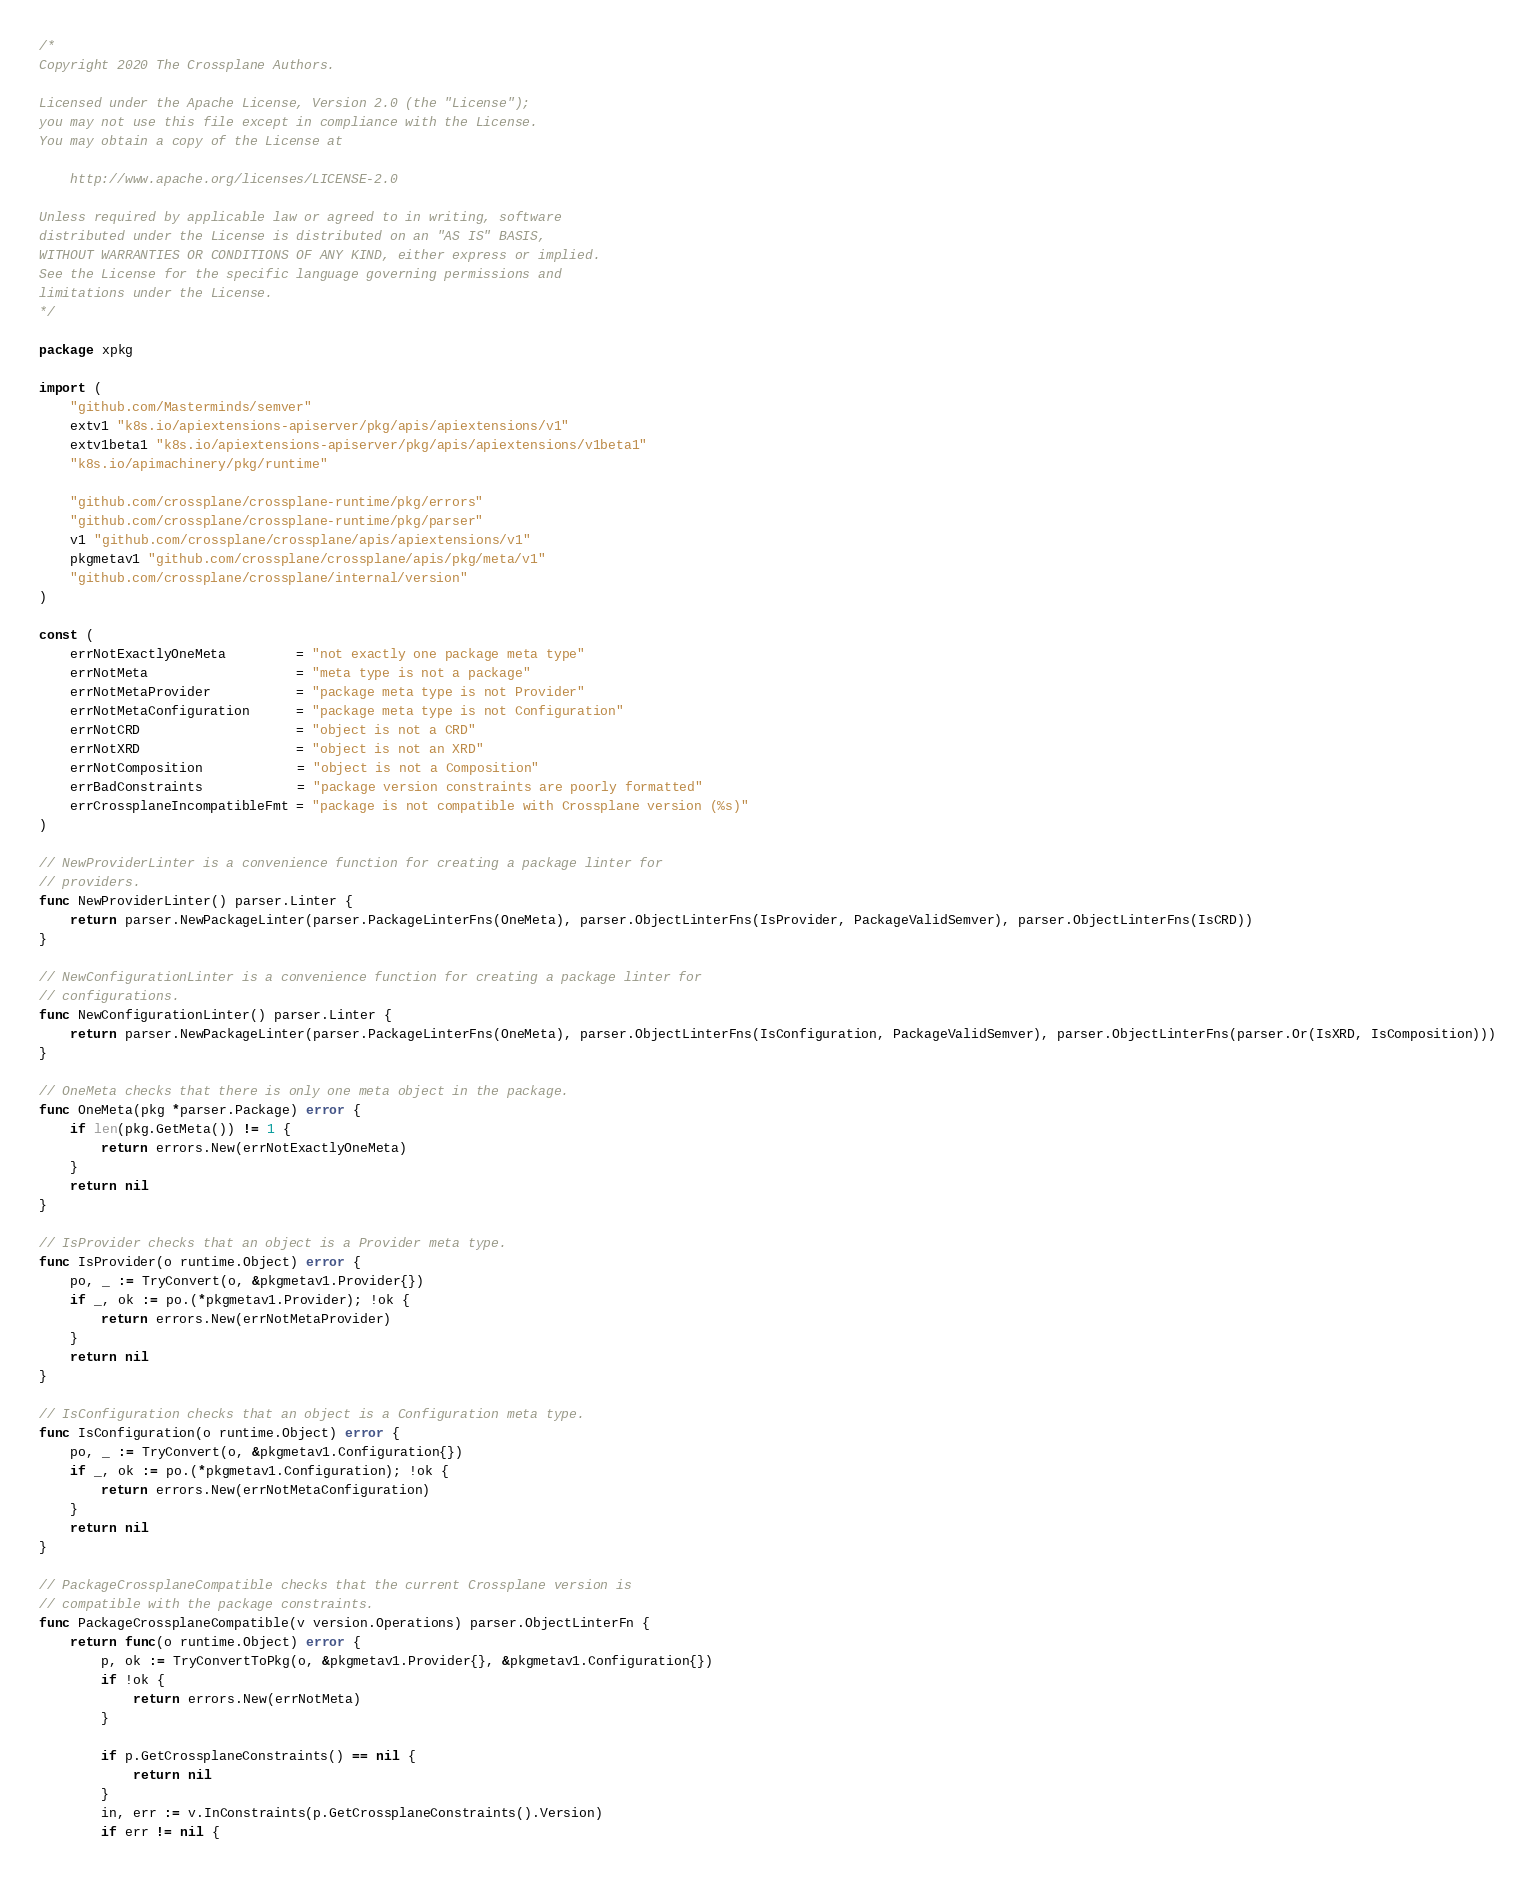Convert code to text. <code><loc_0><loc_0><loc_500><loc_500><_Go_>/*
Copyright 2020 The Crossplane Authors.

Licensed under the Apache License, Version 2.0 (the "License");
you may not use this file except in compliance with the License.
You may obtain a copy of the License at

    http://www.apache.org/licenses/LICENSE-2.0

Unless required by applicable law or agreed to in writing, software
distributed under the License is distributed on an "AS IS" BASIS,
WITHOUT WARRANTIES OR CONDITIONS OF ANY KIND, either express or implied.
See the License for the specific language governing permissions and
limitations under the License.
*/

package xpkg

import (
	"github.com/Masterminds/semver"
	extv1 "k8s.io/apiextensions-apiserver/pkg/apis/apiextensions/v1"
	extv1beta1 "k8s.io/apiextensions-apiserver/pkg/apis/apiextensions/v1beta1"
	"k8s.io/apimachinery/pkg/runtime"

	"github.com/crossplane/crossplane-runtime/pkg/errors"
	"github.com/crossplane/crossplane-runtime/pkg/parser"
	v1 "github.com/crossplane/crossplane/apis/apiextensions/v1"
	pkgmetav1 "github.com/crossplane/crossplane/apis/pkg/meta/v1"
	"github.com/crossplane/crossplane/internal/version"
)

const (
	errNotExactlyOneMeta         = "not exactly one package meta type"
	errNotMeta                   = "meta type is not a package"
	errNotMetaProvider           = "package meta type is not Provider"
	errNotMetaConfiguration      = "package meta type is not Configuration"
	errNotCRD                    = "object is not a CRD"
	errNotXRD                    = "object is not an XRD"
	errNotComposition            = "object is not a Composition"
	errBadConstraints            = "package version constraints are poorly formatted"
	errCrossplaneIncompatibleFmt = "package is not compatible with Crossplane version (%s)"
)

// NewProviderLinter is a convenience function for creating a package linter for
// providers.
func NewProviderLinter() parser.Linter {
	return parser.NewPackageLinter(parser.PackageLinterFns(OneMeta), parser.ObjectLinterFns(IsProvider, PackageValidSemver), parser.ObjectLinterFns(IsCRD))
}

// NewConfigurationLinter is a convenience function for creating a package linter for
// configurations.
func NewConfigurationLinter() parser.Linter {
	return parser.NewPackageLinter(parser.PackageLinterFns(OneMeta), parser.ObjectLinterFns(IsConfiguration, PackageValidSemver), parser.ObjectLinterFns(parser.Or(IsXRD, IsComposition)))
}

// OneMeta checks that there is only one meta object in the package.
func OneMeta(pkg *parser.Package) error {
	if len(pkg.GetMeta()) != 1 {
		return errors.New(errNotExactlyOneMeta)
	}
	return nil
}

// IsProvider checks that an object is a Provider meta type.
func IsProvider(o runtime.Object) error {
	po, _ := TryConvert(o, &pkgmetav1.Provider{})
	if _, ok := po.(*pkgmetav1.Provider); !ok {
		return errors.New(errNotMetaProvider)
	}
	return nil
}

// IsConfiguration checks that an object is a Configuration meta type.
func IsConfiguration(o runtime.Object) error {
	po, _ := TryConvert(o, &pkgmetav1.Configuration{})
	if _, ok := po.(*pkgmetav1.Configuration); !ok {
		return errors.New(errNotMetaConfiguration)
	}
	return nil
}

// PackageCrossplaneCompatible checks that the current Crossplane version is
// compatible with the package constraints.
func PackageCrossplaneCompatible(v version.Operations) parser.ObjectLinterFn {
	return func(o runtime.Object) error {
		p, ok := TryConvertToPkg(o, &pkgmetav1.Provider{}, &pkgmetav1.Configuration{})
		if !ok {
			return errors.New(errNotMeta)
		}

		if p.GetCrossplaneConstraints() == nil {
			return nil
		}
		in, err := v.InConstraints(p.GetCrossplaneConstraints().Version)
		if err != nil {</code> 